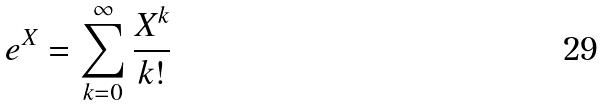<formula> <loc_0><loc_0><loc_500><loc_500>e ^ { X } = \sum _ { k = 0 } ^ { \infty } \frac { X ^ { k } } { k ! }</formula> 